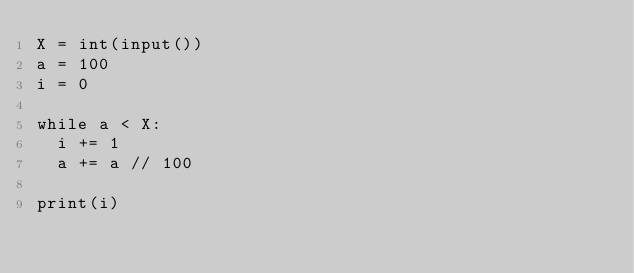<code> <loc_0><loc_0><loc_500><loc_500><_Python_>X = int(input())
a = 100
i = 0

while a < X:
  i += 1
  a += a // 100
  
print(i)</code> 